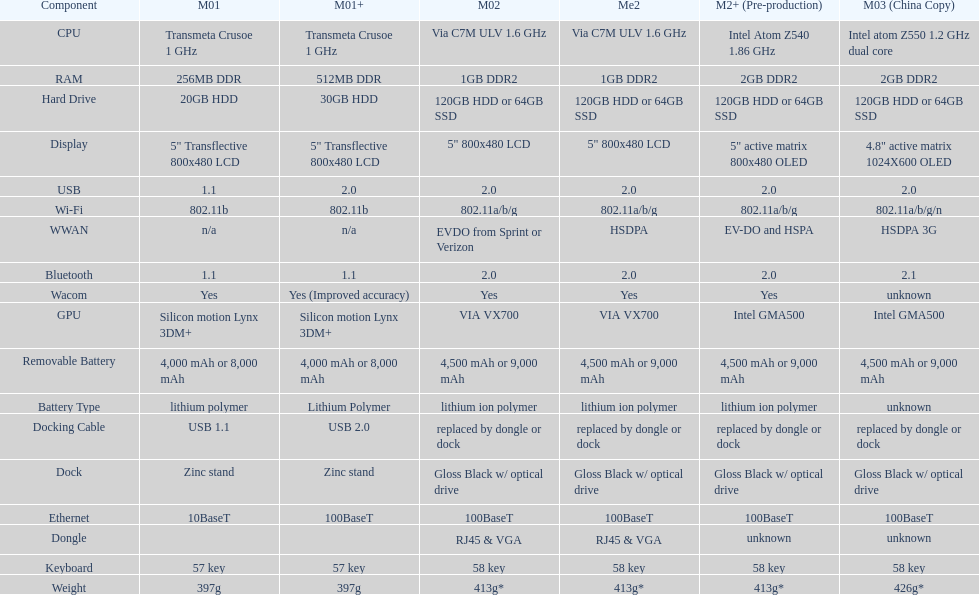What component comes after bluetooth? Wacom. 